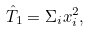<formula> <loc_0><loc_0><loc_500><loc_500>\hat { T } _ { 1 } = \Sigma _ { i } x _ { i } ^ { 2 } ,</formula> 